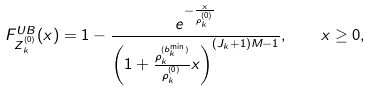<formula> <loc_0><loc_0><loc_500><loc_500>F _ { Z _ { k } ^ { ( 0 ) } } ^ { U B } ( x ) = 1 - \frac { e ^ { - \frac { x } { \rho _ { k } ^ { ( 0 ) } } } } { \left ( 1 + \frac { \rho _ { k } ^ { ( b _ { k } ^ { \min } ) } } { \rho _ { k } ^ { ( 0 ) } } x \right ) ^ { ( J _ { k } + 1 ) M - 1 } } , \quad x \geq 0 ,</formula> 